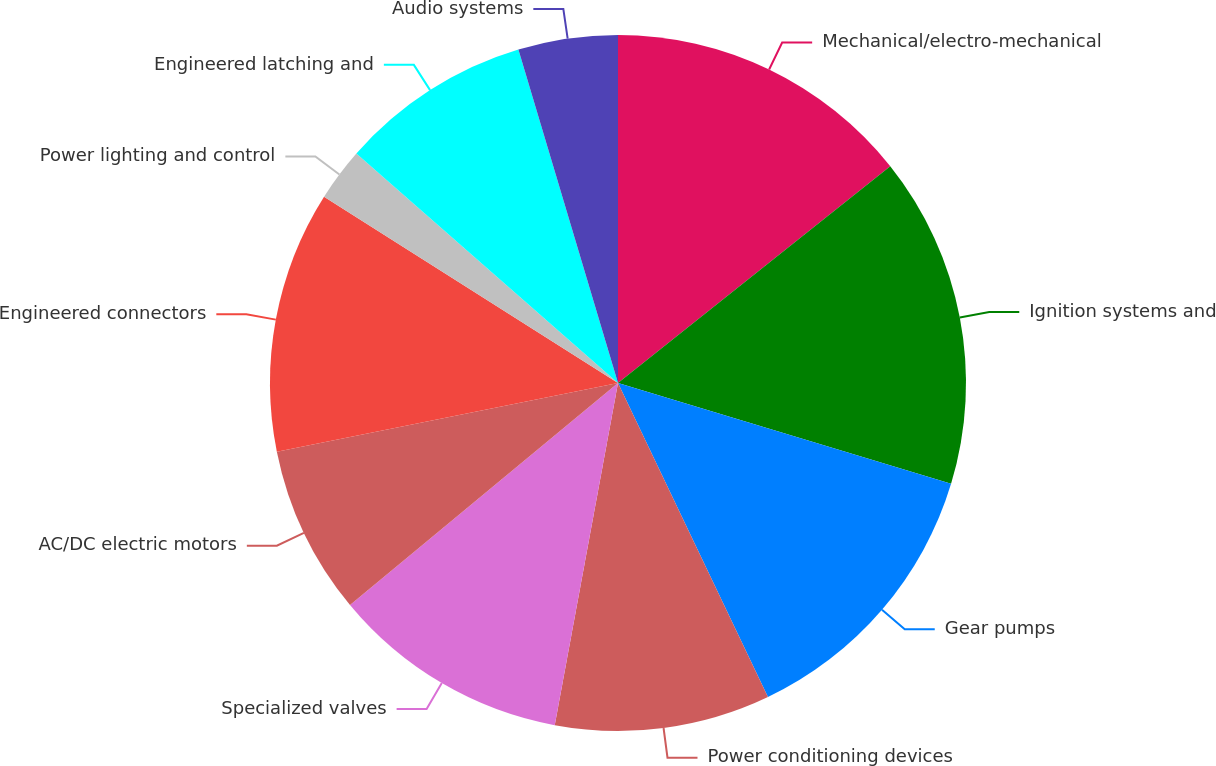Convert chart. <chart><loc_0><loc_0><loc_500><loc_500><pie_chart><fcel>Mechanical/electro-mechanical<fcel>Ignition systems and<fcel>Gear pumps<fcel>Power conditioning devices<fcel>Specialized valves<fcel>AC/DC electric motors<fcel>Engineered connectors<fcel>Power lighting and control<fcel>Engineered latching and<fcel>Audio systems<nl><fcel>14.3%<fcel>15.38%<fcel>13.23%<fcel>10.0%<fcel>11.08%<fcel>7.85%<fcel>12.15%<fcel>2.47%<fcel>8.92%<fcel>4.62%<nl></chart> 